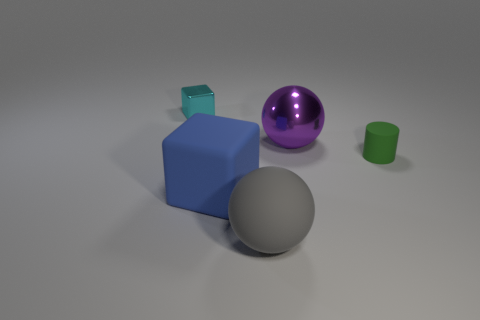Add 1 cyan cubes. How many objects exist? 6 Subtract all cylinders. How many objects are left? 4 Add 1 cyan cubes. How many cyan cubes are left? 2 Add 3 big rubber things. How many big rubber things exist? 5 Subtract 0 cyan cylinders. How many objects are left? 5 Subtract all big gray objects. Subtract all big objects. How many objects are left? 1 